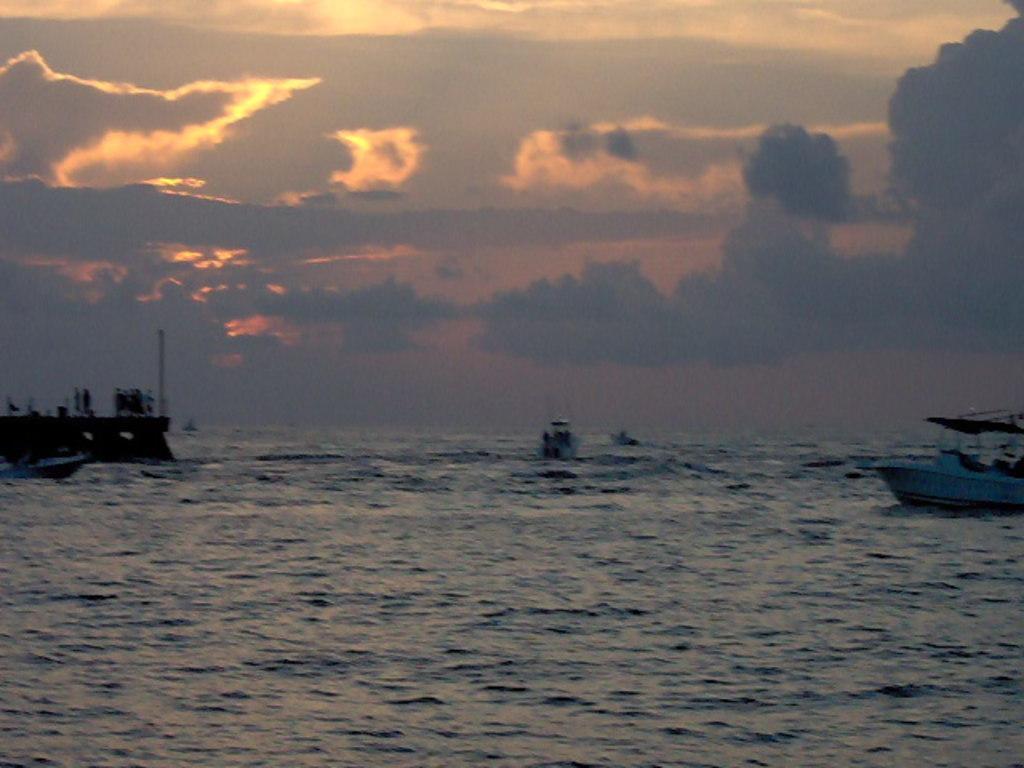Could you give a brief overview of what you see in this image? There are boats on the water of the ocean. In the background, there are clouds in the sky. 